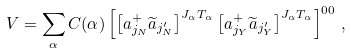<formula> <loc_0><loc_0><loc_500><loc_500>V = \sum _ { \alpha } C ( \alpha ) \left [ \left [ a ^ { + } _ { j _ { N } } \widetilde { a } _ { j _ { N } ^ { \prime } } \right ] ^ { J _ { \alpha } T _ { \alpha } } \left [ a ^ { + } _ { j _ { Y } } \widetilde { a } _ { j _ { Y } ^ { \prime } } \right ] ^ { J _ { \alpha } T _ { \alpha } } \right ] ^ { 0 0 } \, ,</formula> 